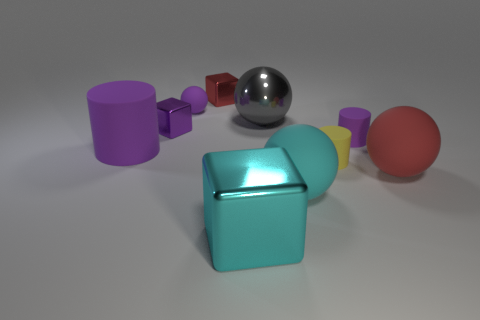What number of purple things are either cylinders or tiny cylinders?
Offer a very short reply. 2. How many things are both right of the red metallic object and in front of the purple metallic thing?
Give a very brief answer. 5. Is the material of the large gray ball the same as the big block?
Make the answer very short. Yes. There is a gray metal object that is the same size as the red rubber sphere; what is its shape?
Give a very brief answer. Sphere. Are there more purple objects than large things?
Provide a short and direct response. No. There is a tiny object that is both behind the small purple rubber cylinder and right of the small purple sphere; what material is it?
Keep it short and to the point. Metal. What number of other objects are there of the same material as the big red ball?
Your answer should be compact. 5. What number of small matte things have the same color as the metal sphere?
Offer a terse response. 0. There is a metal block that is left of the sphere behind the gray shiny thing on the left side of the yellow cylinder; what is its size?
Your answer should be compact. Small. How many shiny objects are big purple cylinders or spheres?
Offer a terse response. 1. 